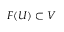<formula> <loc_0><loc_0><loc_500><loc_500>F ( U ) \subset V</formula> 